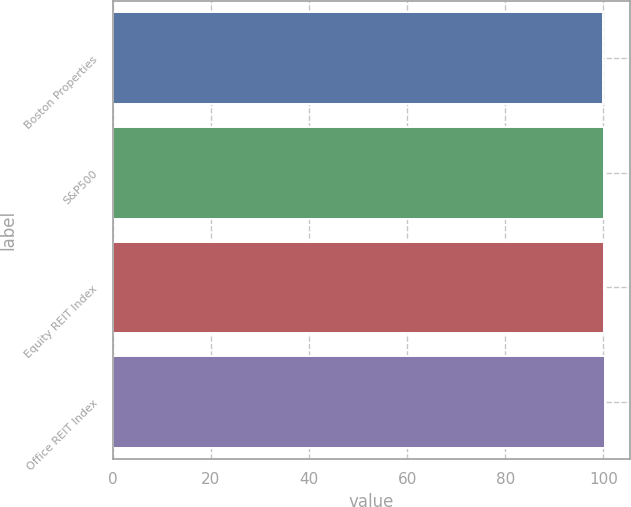Convert chart. <chart><loc_0><loc_0><loc_500><loc_500><bar_chart><fcel>Boston Properties<fcel>S&P500<fcel>Equity REIT Index<fcel>Office REIT Index<nl><fcel>100<fcel>100.1<fcel>100.2<fcel>100.3<nl></chart> 